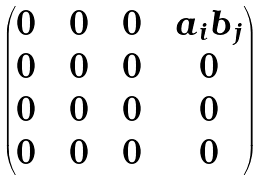<formula> <loc_0><loc_0><loc_500><loc_500>\begin{pmatrix} 0 & & 0 & & 0 & & a _ { i } b _ { j } \\ 0 & & 0 & & 0 & & 0 \\ 0 & & 0 & & 0 & & 0 \\ 0 & & 0 & & 0 & & 0 \\ \end{pmatrix}</formula> 